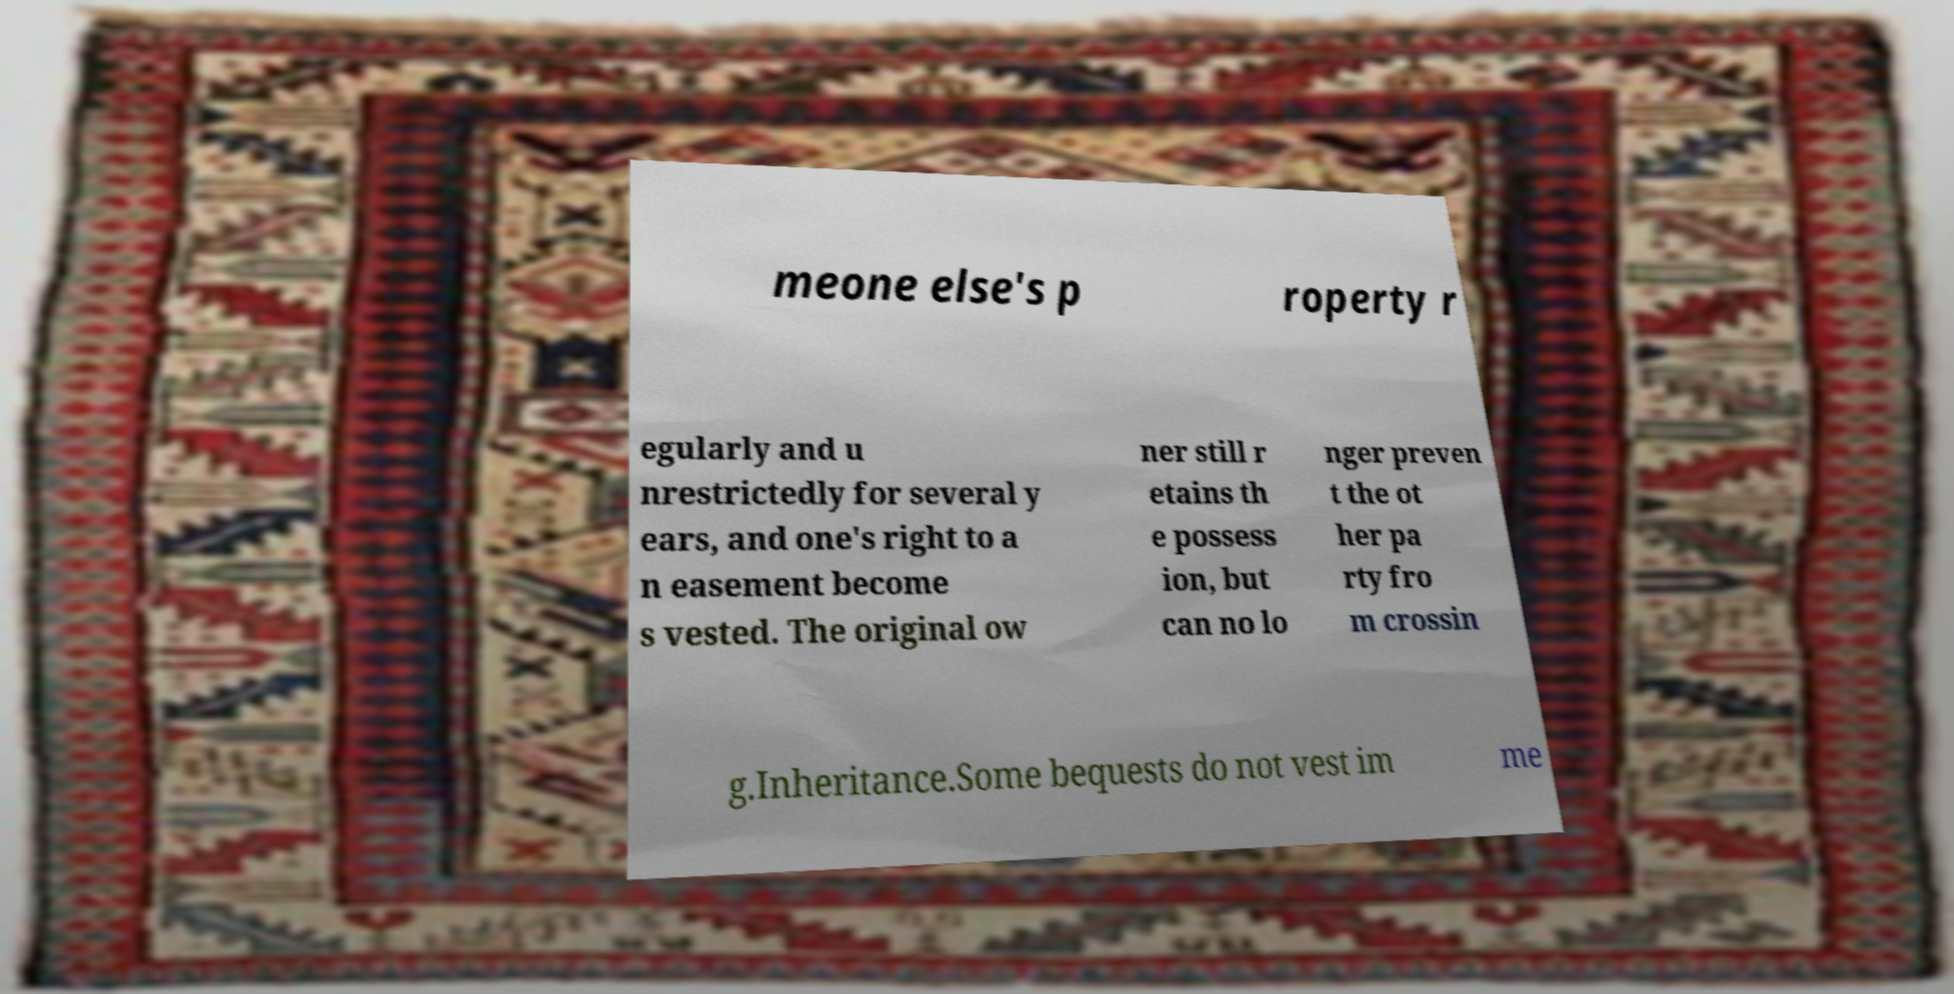Please read and relay the text visible in this image. What does it say? meone else's p roperty r egularly and u nrestrictedly for several y ears, and one's right to a n easement become s vested. The original ow ner still r etains th e possess ion, but can no lo nger preven t the ot her pa rty fro m crossin g.Inheritance.Some bequests do not vest im me 